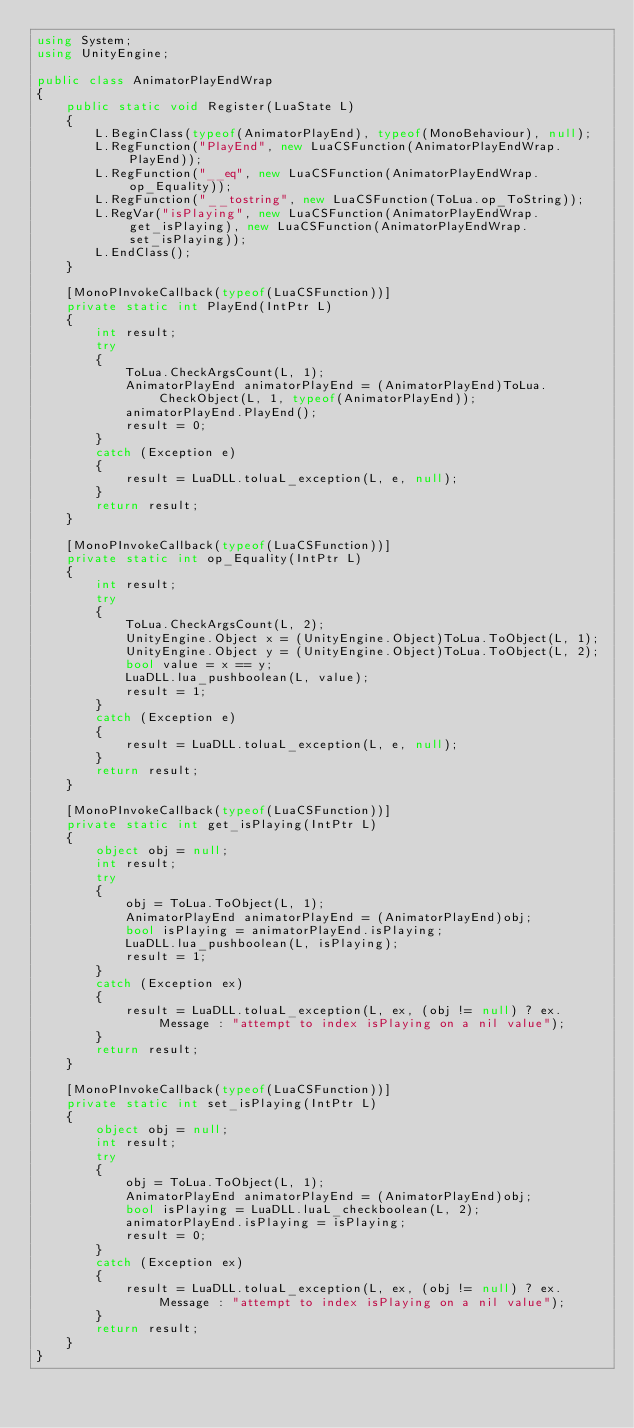<code> <loc_0><loc_0><loc_500><loc_500><_C#_>using System;
using UnityEngine;

public class AnimatorPlayEndWrap
{
	public static void Register(LuaState L)
	{
		L.BeginClass(typeof(AnimatorPlayEnd), typeof(MonoBehaviour), null);
		L.RegFunction("PlayEnd", new LuaCSFunction(AnimatorPlayEndWrap.PlayEnd));
		L.RegFunction("__eq", new LuaCSFunction(AnimatorPlayEndWrap.op_Equality));
		L.RegFunction("__tostring", new LuaCSFunction(ToLua.op_ToString));
		L.RegVar("isPlaying", new LuaCSFunction(AnimatorPlayEndWrap.get_isPlaying), new LuaCSFunction(AnimatorPlayEndWrap.set_isPlaying));
		L.EndClass();
	}

	[MonoPInvokeCallback(typeof(LuaCSFunction))]
	private static int PlayEnd(IntPtr L)
	{
		int result;
		try
		{
			ToLua.CheckArgsCount(L, 1);
			AnimatorPlayEnd animatorPlayEnd = (AnimatorPlayEnd)ToLua.CheckObject(L, 1, typeof(AnimatorPlayEnd));
			animatorPlayEnd.PlayEnd();
			result = 0;
		}
		catch (Exception e)
		{
			result = LuaDLL.toluaL_exception(L, e, null);
		}
		return result;
	}

	[MonoPInvokeCallback(typeof(LuaCSFunction))]
	private static int op_Equality(IntPtr L)
	{
		int result;
		try
		{
			ToLua.CheckArgsCount(L, 2);
			UnityEngine.Object x = (UnityEngine.Object)ToLua.ToObject(L, 1);
			UnityEngine.Object y = (UnityEngine.Object)ToLua.ToObject(L, 2);
			bool value = x == y;
			LuaDLL.lua_pushboolean(L, value);
			result = 1;
		}
		catch (Exception e)
		{
			result = LuaDLL.toluaL_exception(L, e, null);
		}
		return result;
	}

	[MonoPInvokeCallback(typeof(LuaCSFunction))]
	private static int get_isPlaying(IntPtr L)
	{
		object obj = null;
		int result;
		try
		{
			obj = ToLua.ToObject(L, 1);
			AnimatorPlayEnd animatorPlayEnd = (AnimatorPlayEnd)obj;
			bool isPlaying = animatorPlayEnd.isPlaying;
			LuaDLL.lua_pushboolean(L, isPlaying);
			result = 1;
		}
		catch (Exception ex)
		{
			result = LuaDLL.toluaL_exception(L, ex, (obj != null) ? ex.Message : "attempt to index isPlaying on a nil value");
		}
		return result;
	}

	[MonoPInvokeCallback(typeof(LuaCSFunction))]
	private static int set_isPlaying(IntPtr L)
	{
		object obj = null;
		int result;
		try
		{
			obj = ToLua.ToObject(L, 1);
			AnimatorPlayEnd animatorPlayEnd = (AnimatorPlayEnd)obj;
			bool isPlaying = LuaDLL.luaL_checkboolean(L, 2);
			animatorPlayEnd.isPlaying = isPlaying;
			result = 0;
		}
		catch (Exception ex)
		{
			result = LuaDLL.toluaL_exception(L, ex, (obj != null) ? ex.Message : "attempt to index isPlaying on a nil value");
		}
		return result;
	}
}
</code> 